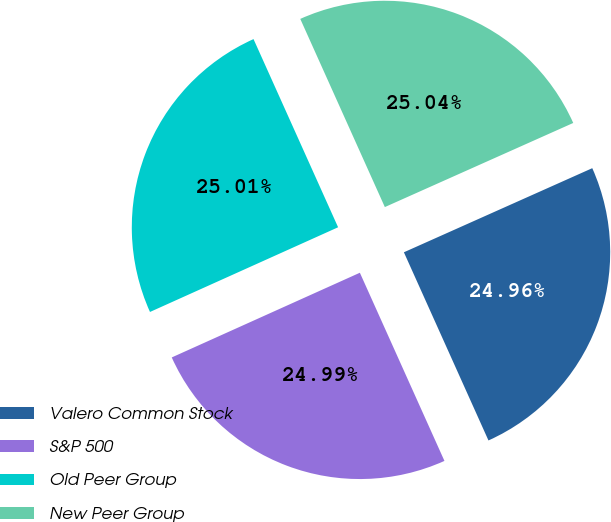Convert chart to OTSL. <chart><loc_0><loc_0><loc_500><loc_500><pie_chart><fcel>Valero Common Stock<fcel>S&P 500<fcel>Old Peer Group<fcel>New Peer Group<nl><fcel>24.96%<fcel>24.99%<fcel>25.01%<fcel>25.04%<nl></chart> 